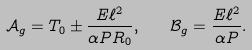<formula> <loc_0><loc_0><loc_500><loc_500>\mathcal { A } _ { g } = T _ { 0 } \pm \frac { E \ell ^ { 2 } } { \alpha P R _ { 0 } } , \quad \mathcal { B } _ { g } = \frac { E \ell ^ { 2 } } { \alpha P } .</formula> 